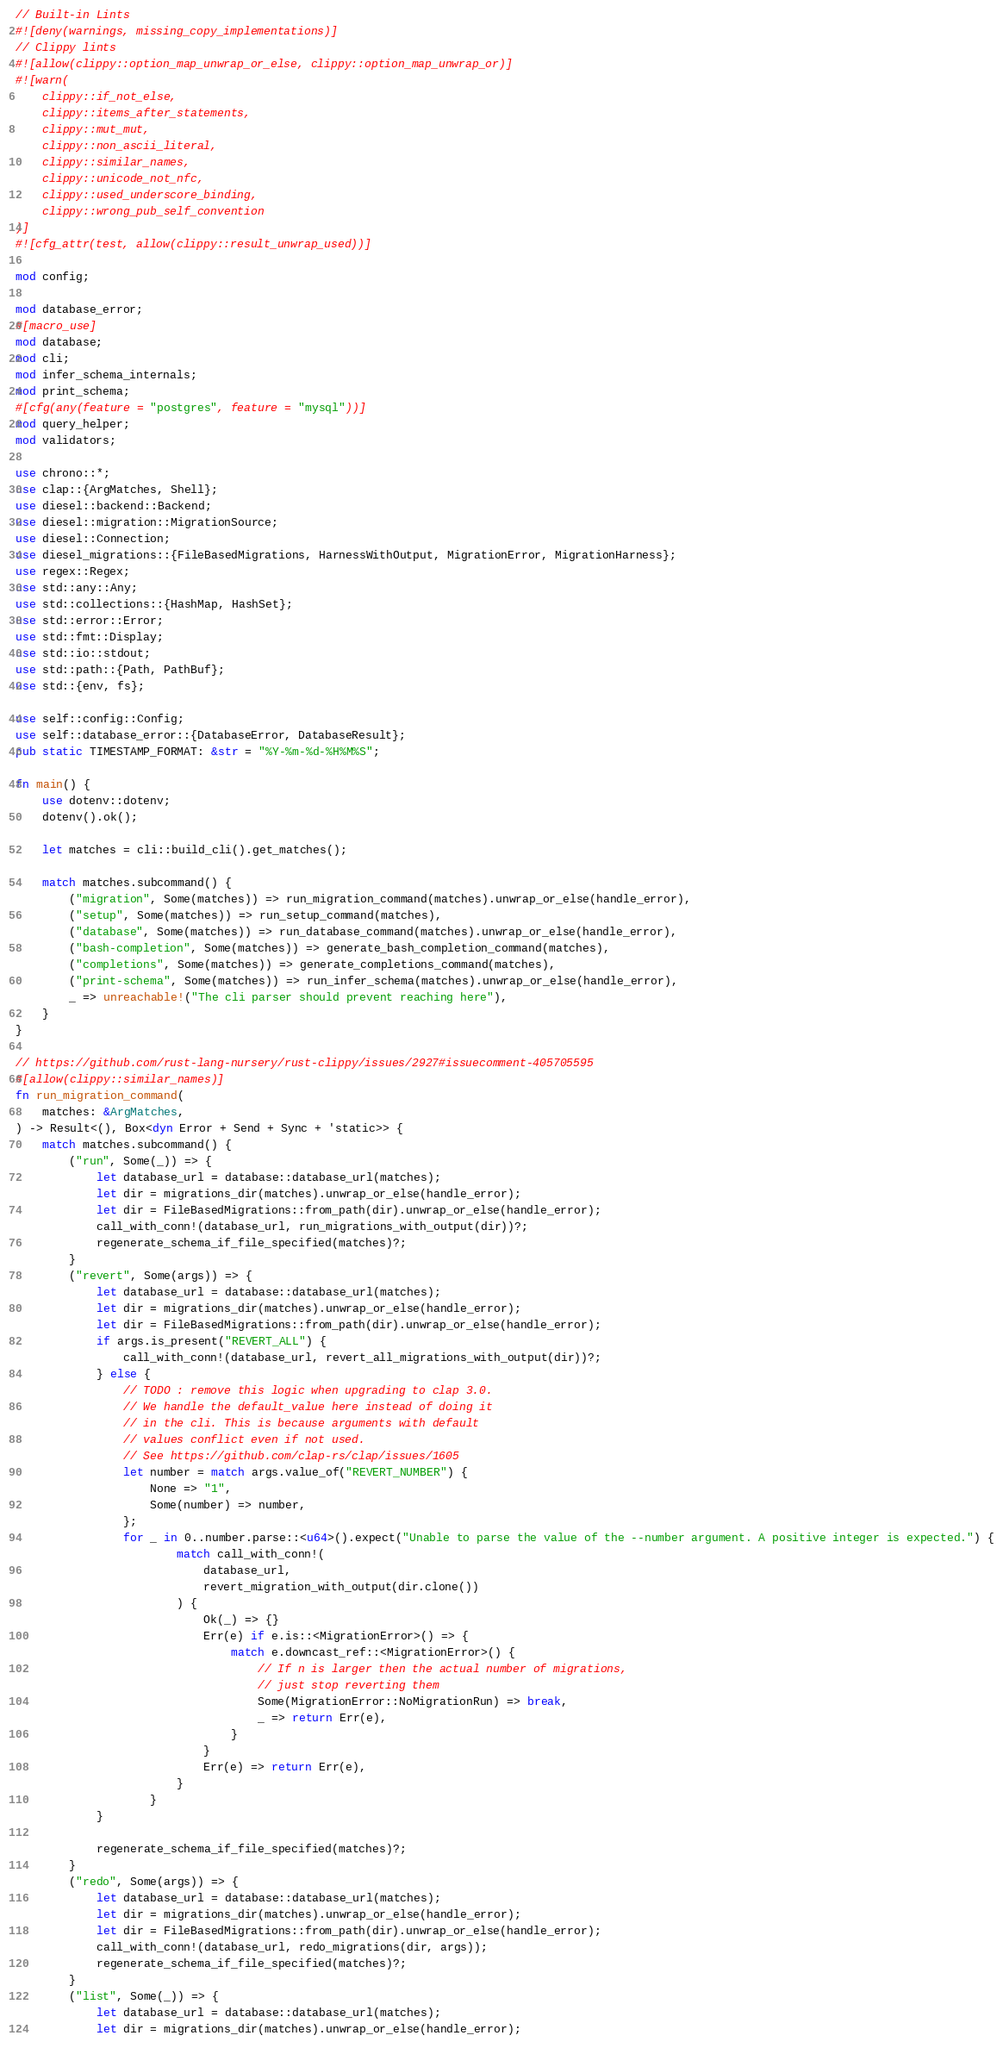Convert code to text. <code><loc_0><loc_0><loc_500><loc_500><_Rust_>// Built-in Lints
#![deny(warnings, missing_copy_implementations)]
// Clippy lints
#![allow(clippy::option_map_unwrap_or_else, clippy::option_map_unwrap_or)]
#![warn(
    clippy::if_not_else,
    clippy::items_after_statements,
    clippy::mut_mut,
    clippy::non_ascii_literal,
    clippy::similar_names,
    clippy::unicode_not_nfc,
    clippy::used_underscore_binding,
    clippy::wrong_pub_self_convention
)]
#![cfg_attr(test, allow(clippy::result_unwrap_used))]

mod config;

mod database_error;
#[macro_use]
mod database;
mod cli;
mod infer_schema_internals;
mod print_schema;
#[cfg(any(feature = "postgres", feature = "mysql"))]
mod query_helper;
mod validators;

use chrono::*;
use clap::{ArgMatches, Shell};
use diesel::backend::Backend;
use diesel::migration::MigrationSource;
use diesel::Connection;
use diesel_migrations::{FileBasedMigrations, HarnessWithOutput, MigrationError, MigrationHarness};
use regex::Regex;
use std::any::Any;
use std::collections::{HashMap, HashSet};
use std::error::Error;
use std::fmt::Display;
use std::io::stdout;
use std::path::{Path, PathBuf};
use std::{env, fs};

use self::config::Config;
use self::database_error::{DatabaseError, DatabaseResult};
pub static TIMESTAMP_FORMAT: &str = "%Y-%m-%d-%H%M%S";

fn main() {
    use dotenv::dotenv;
    dotenv().ok();

    let matches = cli::build_cli().get_matches();

    match matches.subcommand() {
        ("migration", Some(matches)) => run_migration_command(matches).unwrap_or_else(handle_error),
        ("setup", Some(matches)) => run_setup_command(matches),
        ("database", Some(matches)) => run_database_command(matches).unwrap_or_else(handle_error),
        ("bash-completion", Some(matches)) => generate_bash_completion_command(matches),
        ("completions", Some(matches)) => generate_completions_command(matches),
        ("print-schema", Some(matches)) => run_infer_schema(matches).unwrap_or_else(handle_error),
        _ => unreachable!("The cli parser should prevent reaching here"),
    }
}

// https://github.com/rust-lang-nursery/rust-clippy/issues/2927#issuecomment-405705595
#[allow(clippy::similar_names)]
fn run_migration_command(
    matches: &ArgMatches,
) -> Result<(), Box<dyn Error + Send + Sync + 'static>> {
    match matches.subcommand() {
        ("run", Some(_)) => {
            let database_url = database::database_url(matches);
            let dir = migrations_dir(matches).unwrap_or_else(handle_error);
            let dir = FileBasedMigrations::from_path(dir).unwrap_or_else(handle_error);
            call_with_conn!(database_url, run_migrations_with_output(dir))?;
            regenerate_schema_if_file_specified(matches)?;
        }
        ("revert", Some(args)) => {
            let database_url = database::database_url(matches);
            let dir = migrations_dir(matches).unwrap_or_else(handle_error);
            let dir = FileBasedMigrations::from_path(dir).unwrap_or_else(handle_error);
            if args.is_present("REVERT_ALL") {
                call_with_conn!(database_url, revert_all_migrations_with_output(dir))?;
            } else {
                // TODO : remove this logic when upgrading to clap 3.0.
                // We handle the default_value here instead of doing it
                // in the cli. This is because arguments with default
                // values conflict even if not used.
                // See https://github.com/clap-rs/clap/issues/1605
                let number = match args.value_of("REVERT_NUMBER") {
                    None => "1",
                    Some(number) => number,
                };
                for _ in 0..number.parse::<u64>().expect("Unable to parse the value of the --number argument. A positive integer is expected.") {
                        match call_with_conn!(
                            database_url,
                            revert_migration_with_output(dir.clone())
                        ) {
                            Ok(_) => {}
                            Err(e) if e.is::<MigrationError>() => {
                                match e.downcast_ref::<MigrationError>() {
                                    // If n is larger then the actual number of migrations,
                                    // just stop reverting them
                                    Some(MigrationError::NoMigrationRun) => break,
                                    _ => return Err(e),
                                }
                            }
                            Err(e) => return Err(e),
                        }
                    }
            }

            regenerate_schema_if_file_specified(matches)?;
        }
        ("redo", Some(args)) => {
            let database_url = database::database_url(matches);
            let dir = migrations_dir(matches).unwrap_or_else(handle_error);
            let dir = FileBasedMigrations::from_path(dir).unwrap_or_else(handle_error);
            call_with_conn!(database_url, redo_migrations(dir, args));
            regenerate_schema_if_file_specified(matches)?;
        }
        ("list", Some(_)) => {
            let database_url = database::database_url(matches);
            let dir = migrations_dir(matches).unwrap_or_else(handle_error);</code> 